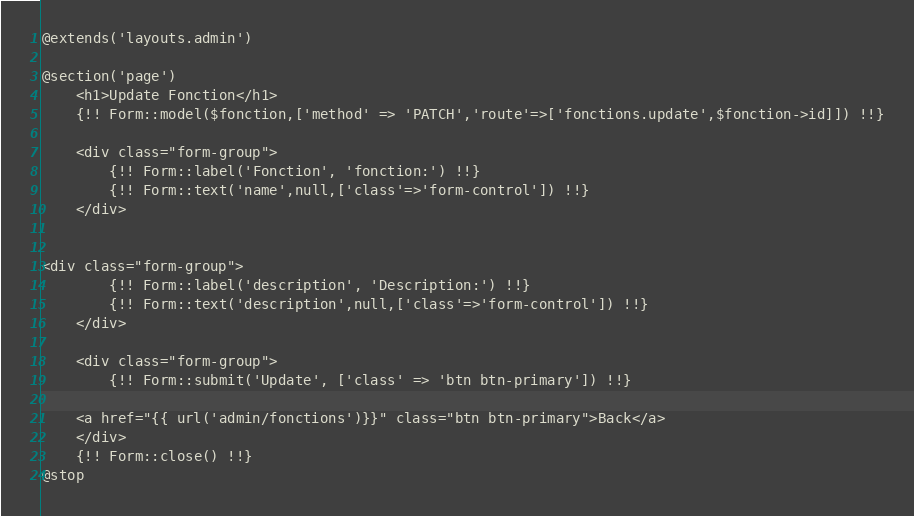Convert code to text. <code><loc_0><loc_0><loc_500><loc_500><_PHP_>@extends('layouts.admin')

@section('page')
    <h1>Update Fonction</h1>
    {!! Form::model($fonction,['method' => 'PATCH','route'=>['fonctions.update',$fonction->id]]) !!}
    
    <div class="form-group">
        {!! Form::label('Fonction', 'fonction:') !!}
        {!! Form::text('name',null,['class'=>'form-control']) !!}
    </div>


<div class="form-group">
        {!! Form::label('description', 'Description:') !!}
        {!! Form::text('description',null,['class'=>'form-control']) !!}
    </div>

    <div class="form-group">
        {!! Form::submit('Update', ['class' => 'btn btn-primary']) !!}
    
    <a href="{{ url('admin/fonctions')}}" class="btn btn-primary">Back</a>
    </div>
    {!! Form::close() !!}
@stop</code> 